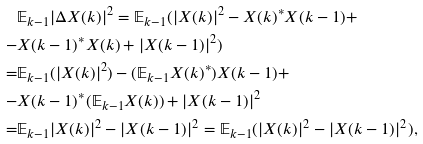Convert formula to latex. <formula><loc_0><loc_0><loc_500><loc_500>& \mathbb { E } _ { k - 1 } | \Delta X ( k ) | ^ { 2 } = \mathbb { E } _ { k - 1 } ( | X ( k ) | ^ { 2 } - X ( k ) ^ { * } X ( k - 1 ) + \\ - & X ( k - 1 ) ^ { * } X ( k ) + | X ( k - 1 ) | ^ { 2 } ) \\ = & \mathbb { E } _ { k - 1 } ( | X ( k ) | ^ { 2 } ) - ( \mathbb { E } _ { k - 1 } X ( k ) ^ { * } ) X ( k - 1 ) + \\ - & X ( k - 1 ) ^ { * } ( \mathbb { E } _ { k - 1 } X ( k ) ) + | X ( k - 1 ) | ^ { 2 } \\ = & \mathbb { E } _ { k - 1 } | X ( k ) | ^ { 2 } - | X ( k - 1 ) | ^ { 2 } = \mathbb { E } _ { k - 1 } ( | X ( k ) | ^ { 2 } - | X ( k - 1 ) | ^ { 2 } ) ,</formula> 